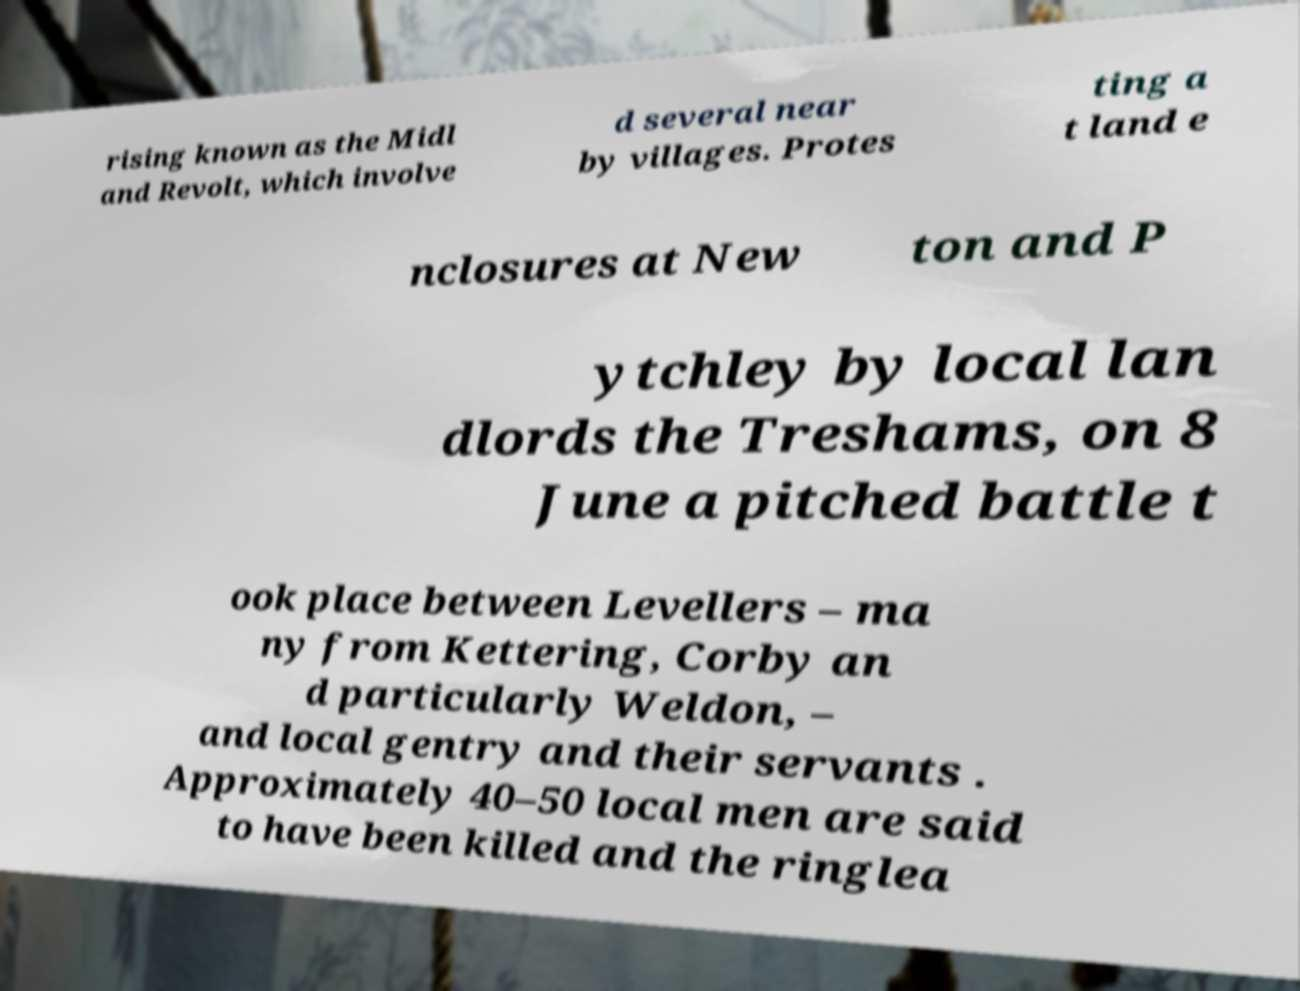I need the written content from this picture converted into text. Can you do that? rising known as the Midl and Revolt, which involve d several near by villages. Protes ting a t land e nclosures at New ton and P ytchley by local lan dlords the Treshams, on 8 June a pitched battle t ook place between Levellers – ma ny from Kettering, Corby an d particularly Weldon, – and local gentry and their servants . Approximately 40–50 local men are said to have been killed and the ringlea 